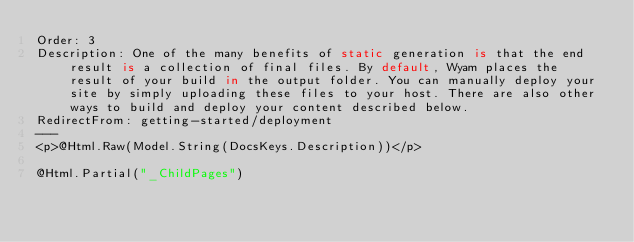Convert code to text. <code><loc_0><loc_0><loc_500><loc_500><_C#_>Order: 3
Description: One of the many benefits of static generation is that the end result is a collection of final files. By default, Wyam places the result of your build in the output folder. You can manually deploy your site by simply uploading these files to your host. There are also other ways to build and deploy your content described below.
RedirectFrom: getting-started/deployment
---
<p>@Html.Raw(Model.String(DocsKeys.Description))</p>

@Html.Partial("_ChildPages")</code> 